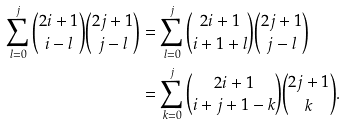Convert formula to latex. <formula><loc_0><loc_0><loc_500><loc_500>\sum _ { l = 0 } ^ { j } { 2 i + 1 \choose i - l } { 2 j + 1 \choose j - l } & = \sum _ { l = 0 } ^ { j } { 2 i + 1 \choose i + 1 + l } { 2 j + 1 \choose j - l } \\ & = \sum _ { k = 0 } ^ { j } { 2 i + 1 \choose i + j + 1 - k } { 2 j + 1 \choose k } .</formula> 